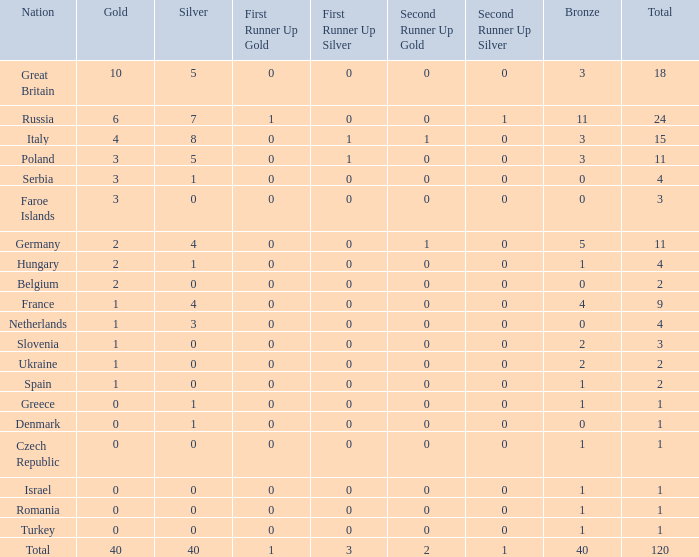What is Turkey's average Gold entry that also has a Bronze entry that is smaller than 2 and the Total is greater than 1? None. 